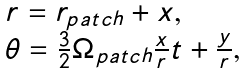Convert formula to latex. <formula><loc_0><loc_0><loc_500><loc_500>\begin{array} { l } r = r _ { p a t c h } + x , \\ \theta = \frac { 3 } { 2 } \Omega _ { p a t c h } \frac { x } { r } t + \frac { y } { r } , \\ \end{array}</formula> 